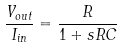<formula> <loc_0><loc_0><loc_500><loc_500>\frac { V _ { o u t } } { I _ { i n } } = \frac { R } { 1 + s R C }</formula> 